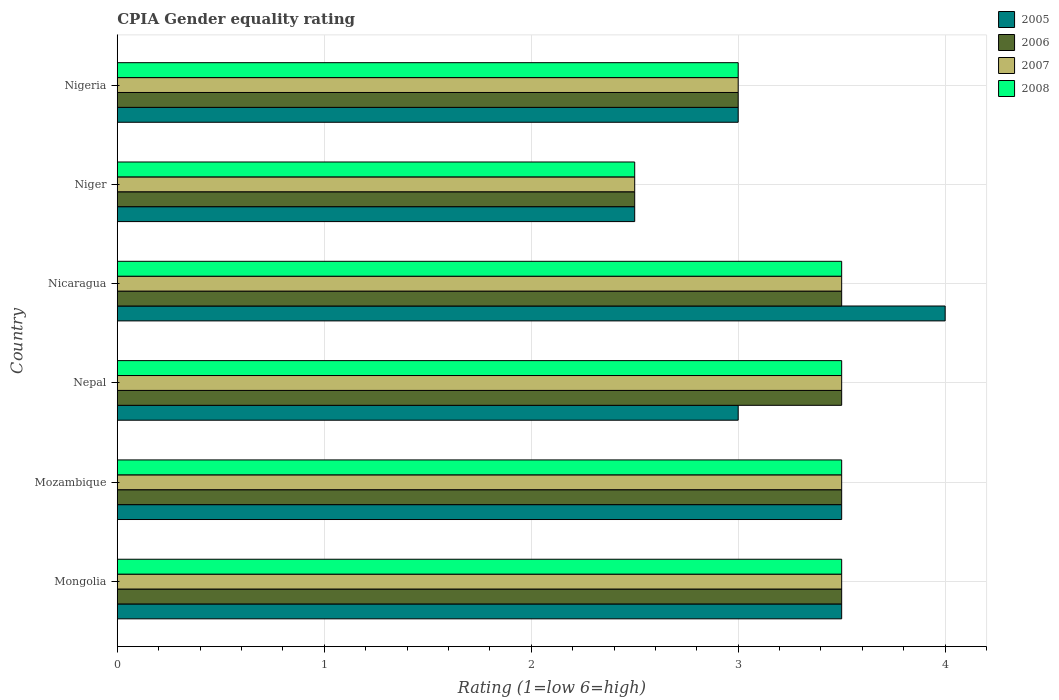Are the number of bars per tick equal to the number of legend labels?
Ensure brevity in your answer.  Yes. Are the number of bars on each tick of the Y-axis equal?
Ensure brevity in your answer.  Yes. How many bars are there on the 2nd tick from the bottom?
Give a very brief answer. 4. What is the label of the 2nd group of bars from the top?
Your answer should be very brief. Niger. In how many cases, is the number of bars for a given country not equal to the number of legend labels?
Make the answer very short. 0. In which country was the CPIA rating in 2007 maximum?
Give a very brief answer. Mongolia. In which country was the CPIA rating in 2006 minimum?
Give a very brief answer. Niger. What is the total CPIA rating in 2005 in the graph?
Your response must be concise. 19.5. What is the difference between the CPIA rating in 2008 in Mongolia and that in Niger?
Keep it short and to the point. 1. What is the difference between the CPIA rating in 2007 in Mozambique and the CPIA rating in 2008 in Nepal?
Your response must be concise. 0. What is the average CPIA rating in 2005 per country?
Offer a very short reply. 3.25. What is the difference between the CPIA rating in 2006 and CPIA rating in 2008 in Mozambique?
Ensure brevity in your answer.  0. What is the difference between the highest and the lowest CPIA rating in 2008?
Your answer should be compact. 1. What does the 2nd bar from the bottom in Nicaragua represents?
Give a very brief answer. 2006. How many bars are there?
Keep it short and to the point. 24. Are all the bars in the graph horizontal?
Give a very brief answer. Yes. What is the difference between two consecutive major ticks on the X-axis?
Your response must be concise. 1. Does the graph contain grids?
Make the answer very short. Yes. How are the legend labels stacked?
Offer a terse response. Vertical. What is the title of the graph?
Your answer should be very brief. CPIA Gender equality rating. Does "1983" appear as one of the legend labels in the graph?
Your response must be concise. No. What is the label or title of the Y-axis?
Offer a terse response. Country. What is the Rating (1=low 6=high) of 2005 in Mongolia?
Offer a very short reply. 3.5. What is the Rating (1=low 6=high) in 2006 in Mongolia?
Give a very brief answer. 3.5. What is the Rating (1=low 6=high) of 2007 in Mozambique?
Offer a terse response. 3.5. What is the Rating (1=low 6=high) in 2008 in Mozambique?
Your answer should be compact. 3.5. What is the Rating (1=low 6=high) of 2005 in Nepal?
Offer a very short reply. 3. What is the Rating (1=low 6=high) of 2006 in Nepal?
Your response must be concise. 3.5. What is the Rating (1=low 6=high) of 2007 in Nepal?
Keep it short and to the point. 3.5. What is the Rating (1=low 6=high) in 2008 in Nepal?
Offer a terse response. 3.5. What is the Rating (1=low 6=high) of 2006 in Niger?
Make the answer very short. 2.5. What is the Rating (1=low 6=high) in 2007 in Niger?
Give a very brief answer. 2.5. What is the Rating (1=low 6=high) of 2006 in Nigeria?
Make the answer very short. 3. What is the Rating (1=low 6=high) in 2007 in Nigeria?
Offer a very short reply. 3. What is the Rating (1=low 6=high) of 2008 in Nigeria?
Make the answer very short. 3. Across all countries, what is the maximum Rating (1=low 6=high) of 2005?
Offer a terse response. 4. Across all countries, what is the maximum Rating (1=low 6=high) of 2007?
Make the answer very short. 3.5. Across all countries, what is the maximum Rating (1=low 6=high) in 2008?
Offer a terse response. 3.5. Across all countries, what is the minimum Rating (1=low 6=high) in 2006?
Keep it short and to the point. 2.5. Across all countries, what is the minimum Rating (1=low 6=high) in 2007?
Provide a short and direct response. 2.5. What is the difference between the Rating (1=low 6=high) in 2005 in Mongolia and that in Mozambique?
Your answer should be very brief. 0. What is the difference between the Rating (1=low 6=high) in 2006 in Mongolia and that in Mozambique?
Your response must be concise. 0. What is the difference between the Rating (1=low 6=high) of 2007 in Mongolia and that in Mozambique?
Give a very brief answer. 0. What is the difference between the Rating (1=low 6=high) of 2005 in Mongolia and that in Nepal?
Provide a succinct answer. 0.5. What is the difference between the Rating (1=low 6=high) in 2006 in Mongolia and that in Nepal?
Offer a very short reply. 0. What is the difference between the Rating (1=low 6=high) in 2007 in Mongolia and that in Nepal?
Your answer should be very brief. 0. What is the difference between the Rating (1=low 6=high) in 2006 in Mongolia and that in Nicaragua?
Keep it short and to the point. 0. What is the difference between the Rating (1=low 6=high) of 2005 in Mongolia and that in Niger?
Offer a terse response. 1. What is the difference between the Rating (1=low 6=high) of 2005 in Mongolia and that in Nigeria?
Ensure brevity in your answer.  0.5. What is the difference between the Rating (1=low 6=high) of 2006 in Mongolia and that in Nigeria?
Your answer should be compact. 0.5. What is the difference between the Rating (1=low 6=high) of 2007 in Mongolia and that in Nigeria?
Give a very brief answer. 0.5. What is the difference between the Rating (1=low 6=high) in 2006 in Mozambique and that in Nepal?
Your answer should be compact. 0. What is the difference between the Rating (1=low 6=high) in 2008 in Mozambique and that in Nicaragua?
Ensure brevity in your answer.  0. What is the difference between the Rating (1=low 6=high) of 2005 in Mozambique and that in Niger?
Offer a very short reply. 1. What is the difference between the Rating (1=low 6=high) of 2005 in Mozambique and that in Nigeria?
Offer a terse response. 0.5. What is the difference between the Rating (1=low 6=high) of 2007 in Mozambique and that in Nigeria?
Your answer should be very brief. 0.5. What is the difference between the Rating (1=low 6=high) in 2005 in Nepal and that in Nicaragua?
Provide a short and direct response. -1. What is the difference between the Rating (1=low 6=high) of 2006 in Nepal and that in Nicaragua?
Offer a terse response. 0. What is the difference between the Rating (1=low 6=high) of 2007 in Nepal and that in Nicaragua?
Ensure brevity in your answer.  0. What is the difference between the Rating (1=low 6=high) of 2006 in Nepal and that in Niger?
Offer a very short reply. 1. What is the difference between the Rating (1=low 6=high) in 2008 in Nepal and that in Niger?
Your answer should be compact. 1. What is the difference between the Rating (1=low 6=high) in 2006 in Nepal and that in Nigeria?
Ensure brevity in your answer.  0.5. What is the difference between the Rating (1=low 6=high) in 2008 in Nepal and that in Nigeria?
Offer a very short reply. 0.5. What is the difference between the Rating (1=low 6=high) in 2005 in Nicaragua and that in Niger?
Your response must be concise. 1.5. What is the difference between the Rating (1=low 6=high) in 2006 in Nicaragua and that in Niger?
Ensure brevity in your answer.  1. What is the difference between the Rating (1=low 6=high) in 2007 in Nicaragua and that in Niger?
Ensure brevity in your answer.  1. What is the difference between the Rating (1=low 6=high) in 2007 in Nicaragua and that in Nigeria?
Provide a succinct answer. 0.5. What is the difference between the Rating (1=low 6=high) of 2005 in Niger and that in Nigeria?
Offer a very short reply. -0.5. What is the difference between the Rating (1=low 6=high) in 2007 in Niger and that in Nigeria?
Provide a short and direct response. -0.5. What is the difference between the Rating (1=low 6=high) of 2008 in Niger and that in Nigeria?
Provide a short and direct response. -0.5. What is the difference between the Rating (1=low 6=high) of 2005 in Mongolia and the Rating (1=low 6=high) of 2006 in Mozambique?
Provide a succinct answer. 0. What is the difference between the Rating (1=low 6=high) of 2005 in Mongolia and the Rating (1=low 6=high) of 2008 in Mozambique?
Provide a succinct answer. 0. What is the difference between the Rating (1=low 6=high) in 2006 in Mongolia and the Rating (1=low 6=high) in 2008 in Mozambique?
Keep it short and to the point. 0. What is the difference between the Rating (1=low 6=high) of 2005 in Mongolia and the Rating (1=low 6=high) of 2006 in Nepal?
Your response must be concise. 0. What is the difference between the Rating (1=low 6=high) of 2005 in Mongolia and the Rating (1=low 6=high) of 2008 in Nepal?
Make the answer very short. 0. What is the difference between the Rating (1=low 6=high) in 2007 in Mongolia and the Rating (1=low 6=high) in 2008 in Nepal?
Make the answer very short. 0. What is the difference between the Rating (1=low 6=high) in 2005 in Mongolia and the Rating (1=low 6=high) in 2007 in Niger?
Your answer should be very brief. 1. What is the difference between the Rating (1=low 6=high) of 2006 in Mongolia and the Rating (1=low 6=high) of 2008 in Niger?
Your response must be concise. 1. What is the difference between the Rating (1=low 6=high) in 2007 in Mongolia and the Rating (1=low 6=high) in 2008 in Niger?
Offer a very short reply. 1. What is the difference between the Rating (1=low 6=high) in 2005 in Mongolia and the Rating (1=low 6=high) in 2007 in Nigeria?
Provide a short and direct response. 0.5. What is the difference between the Rating (1=low 6=high) of 2005 in Mongolia and the Rating (1=low 6=high) of 2008 in Nigeria?
Your response must be concise. 0.5. What is the difference between the Rating (1=low 6=high) of 2006 in Mongolia and the Rating (1=low 6=high) of 2008 in Nigeria?
Give a very brief answer. 0.5. What is the difference between the Rating (1=low 6=high) in 2007 in Mongolia and the Rating (1=low 6=high) in 2008 in Nigeria?
Provide a short and direct response. 0.5. What is the difference between the Rating (1=low 6=high) in 2006 in Mozambique and the Rating (1=low 6=high) in 2007 in Nepal?
Your answer should be very brief. 0. What is the difference between the Rating (1=low 6=high) in 2006 in Mozambique and the Rating (1=low 6=high) in 2008 in Nepal?
Make the answer very short. 0. What is the difference between the Rating (1=low 6=high) of 2007 in Mozambique and the Rating (1=low 6=high) of 2008 in Nepal?
Offer a very short reply. 0. What is the difference between the Rating (1=low 6=high) in 2005 in Mozambique and the Rating (1=low 6=high) in 2008 in Nicaragua?
Make the answer very short. 0. What is the difference between the Rating (1=low 6=high) in 2006 in Mozambique and the Rating (1=low 6=high) in 2008 in Nicaragua?
Make the answer very short. 0. What is the difference between the Rating (1=low 6=high) of 2005 in Mozambique and the Rating (1=low 6=high) of 2007 in Niger?
Your response must be concise. 1. What is the difference between the Rating (1=low 6=high) in 2005 in Mozambique and the Rating (1=low 6=high) in 2008 in Niger?
Your answer should be very brief. 1. What is the difference between the Rating (1=low 6=high) in 2006 in Mozambique and the Rating (1=low 6=high) in 2007 in Niger?
Ensure brevity in your answer.  1. What is the difference between the Rating (1=low 6=high) of 2006 in Mozambique and the Rating (1=low 6=high) of 2008 in Niger?
Offer a very short reply. 1. What is the difference between the Rating (1=low 6=high) of 2007 in Mozambique and the Rating (1=low 6=high) of 2008 in Niger?
Offer a very short reply. 1. What is the difference between the Rating (1=low 6=high) of 2005 in Mozambique and the Rating (1=low 6=high) of 2007 in Nigeria?
Your answer should be compact. 0.5. What is the difference between the Rating (1=low 6=high) of 2006 in Mozambique and the Rating (1=low 6=high) of 2008 in Nigeria?
Your answer should be very brief. 0.5. What is the difference between the Rating (1=low 6=high) of 2007 in Mozambique and the Rating (1=low 6=high) of 2008 in Nigeria?
Provide a succinct answer. 0.5. What is the difference between the Rating (1=low 6=high) of 2005 in Nepal and the Rating (1=low 6=high) of 2008 in Nicaragua?
Offer a very short reply. -0.5. What is the difference between the Rating (1=low 6=high) of 2007 in Nepal and the Rating (1=low 6=high) of 2008 in Nicaragua?
Your answer should be compact. 0. What is the difference between the Rating (1=low 6=high) of 2005 in Nepal and the Rating (1=low 6=high) of 2006 in Niger?
Offer a terse response. 0.5. What is the difference between the Rating (1=low 6=high) of 2005 in Nepal and the Rating (1=low 6=high) of 2007 in Niger?
Ensure brevity in your answer.  0.5. What is the difference between the Rating (1=low 6=high) in 2005 in Nepal and the Rating (1=low 6=high) in 2008 in Niger?
Give a very brief answer. 0.5. What is the difference between the Rating (1=low 6=high) of 2006 in Nepal and the Rating (1=low 6=high) of 2007 in Niger?
Offer a terse response. 1. What is the difference between the Rating (1=low 6=high) in 2007 in Nepal and the Rating (1=low 6=high) in 2008 in Niger?
Offer a terse response. 1. What is the difference between the Rating (1=low 6=high) in 2005 in Nepal and the Rating (1=low 6=high) in 2006 in Nigeria?
Your answer should be very brief. 0. What is the difference between the Rating (1=low 6=high) of 2006 in Nepal and the Rating (1=low 6=high) of 2007 in Nigeria?
Provide a succinct answer. 0.5. What is the difference between the Rating (1=low 6=high) of 2006 in Nepal and the Rating (1=low 6=high) of 2008 in Nigeria?
Provide a short and direct response. 0.5. What is the difference between the Rating (1=low 6=high) in 2005 in Nicaragua and the Rating (1=low 6=high) in 2007 in Niger?
Provide a short and direct response. 1.5. What is the difference between the Rating (1=low 6=high) of 2006 in Nicaragua and the Rating (1=low 6=high) of 2008 in Niger?
Your response must be concise. 1. What is the difference between the Rating (1=low 6=high) of 2005 in Nicaragua and the Rating (1=low 6=high) of 2006 in Nigeria?
Ensure brevity in your answer.  1. What is the difference between the Rating (1=low 6=high) of 2005 in Nicaragua and the Rating (1=low 6=high) of 2007 in Nigeria?
Keep it short and to the point. 1. What is the difference between the Rating (1=low 6=high) of 2006 in Nicaragua and the Rating (1=low 6=high) of 2007 in Nigeria?
Your answer should be compact. 0.5. What is the difference between the Rating (1=low 6=high) of 2006 in Nicaragua and the Rating (1=low 6=high) of 2008 in Nigeria?
Keep it short and to the point. 0.5. What is the difference between the Rating (1=low 6=high) of 2007 in Nicaragua and the Rating (1=low 6=high) of 2008 in Nigeria?
Provide a short and direct response. 0.5. What is the difference between the Rating (1=low 6=high) of 2005 in Niger and the Rating (1=low 6=high) of 2007 in Nigeria?
Offer a very short reply. -0.5. What is the difference between the Rating (1=low 6=high) in 2006 in Niger and the Rating (1=low 6=high) in 2008 in Nigeria?
Your answer should be compact. -0.5. What is the difference between the Rating (1=low 6=high) of 2007 in Niger and the Rating (1=low 6=high) of 2008 in Nigeria?
Offer a terse response. -0.5. What is the average Rating (1=low 6=high) of 2006 per country?
Your answer should be compact. 3.25. What is the difference between the Rating (1=low 6=high) of 2005 and Rating (1=low 6=high) of 2008 in Mongolia?
Provide a short and direct response. 0. What is the difference between the Rating (1=low 6=high) of 2006 and Rating (1=low 6=high) of 2007 in Mongolia?
Offer a terse response. 0. What is the difference between the Rating (1=low 6=high) of 2006 and Rating (1=low 6=high) of 2008 in Mongolia?
Make the answer very short. 0. What is the difference between the Rating (1=low 6=high) in 2007 and Rating (1=low 6=high) in 2008 in Mongolia?
Make the answer very short. 0. What is the difference between the Rating (1=low 6=high) of 2006 and Rating (1=low 6=high) of 2007 in Mozambique?
Ensure brevity in your answer.  0. What is the difference between the Rating (1=low 6=high) of 2006 and Rating (1=low 6=high) of 2008 in Mozambique?
Give a very brief answer. 0. What is the difference between the Rating (1=low 6=high) in 2007 and Rating (1=low 6=high) in 2008 in Mozambique?
Offer a very short reply. 0. What is the difference between the Rating (1=low 6=high) of 2005 and Rating (1=low 6=high) of 2006 in Nepal?
Your answer should be very brief. -0.5. What is the difference between the Rating (1=low 6=high) of 2006 and Rating (1=low 6=high) of 2007 in Nepal?
Your response must be concise. 0. What is the difference between the Rating (1=low 6=high) of 2006 and Rating (1=low 6=high) of 2008 in Nepal?
Your answer should be compact. 0. What is the difference between the Rating (1=low 6=high) of 2007 and Rating (1=low 6=high) of 2008 in Nepal?
Ensure brevity in your answer.  0. What is the difference between the Rating (1=low 6=high) in 2005 and Rating (1=low 6=high) in 2007 in Nicaragua?
Your answer should be very brief. 0.5. What is the difference between the Rating (1=low 6=high) in 2005 and Rating (1=low 6=high) in 2008 in Nicaragua?
Make the answer very short. 0.5. What is the difference between the Rating (1=low 6=high) in 2007 and Rating (1=low 6=high) in 2008 in Niger?
Give a very brief answer. 0. What is the difference between the Rating (1=low 6=high) of 2005 and Rating (1=low 6=high) of 2008 in Nigeria?
Offer a very short reply. 0. What is the difference between the Rating (1=low 6=high) in 2006 and Rating (1=low 6=high) in 2007 in Nigeria?
Provide a short and direct response. 0. What is the difference between the Rating (1=low 6=high) of 2006 and Rating (1=low 6=high) of 2008 in Nigeria?
Your response must be concise. 0. What is the difference between the Rating (1=low 6=high) of 2007 and Rating (1=low 6=high) of 2008 in Nigeria?
Give a very brief answer. 0. What is the ratio of the Rating (1=low 6=high) in 2006 in Mongolia to that in Mozambique?
Your answer should be very brief. 1. What is the ratio of the Rating (1=low 6=high) of 2008 in Mongolia to that in Mozambique?
Provide a succinct answer. 1. What is the ratio of the Rating (1=low 6=high) of 2005 in Mongolia to that in Nicaragua?
Your answer should be very brief. 0.88. What is the ratio of the Rating (1=low 6=high) in 2007 in Mongolia to that in Nicaragua?
Provide a succinct answer. 1. What is the ratio of the Rating (1=low 6=high) of 2008 in Mongolia to that in Nicaragua?
Offer a very short reply. 1. What is the ratio of the Rating (1=low 6=high) in 2006 in Mongolia to that in Niger?
Make the answer very short. 1.4. What is the ratio of the Rating (1=low 6=high) of 2006 in Mongolia to that in Nigeria?
Offer a terse response. 1.17. What is the ratio of the Rating (1=low 6=high) in 2008 in Mongolia to that in Nigeria?
Offer a very short reply. 1.17. What is the ratio of the Rating (1=low 6=high) of 2005 in Mozambique to that in Nepal?
Keep it short and to the point. 1.17. What is the ratio of the Rating (1=low 6=high) in 2006 in Mozambique to that in Nepal?
Offer a very short reply. 1. What is the ratio of the Rating (1=low 6=high) of 2007 in Mozambique to that in Nepal?
Offer a terse response. 1. What is the ratio of the Rating (1=low 6=high) in 2006 in Mozambique to that in Nicaragua?
Make the answer very short. 1. What is the ratio of the Rating (1=low 6=high) in 2007 in Mozambique to that in Nicaragua?
Keep it short and to the point. 1. What is the ratio of the Rating (1=low 6=high) in 2008 in Mozambique to that in Nicaragua?
Your answer should be compact. 1. What is the ratio of the Rating (1=low 6=high) of 2008 in Mozambique to that in Niger?
Offer a terse response. 1.4. What is the ratio of the Rating (1=low 6=high) in 2005 in Mozambique to that in Nigeria?
Provide a short and direct response. 1.17. What is the ratio of the Rating (1=low 6=high) of 2006 in Mozambique to that in Nigeria?
Make the answer very short. 1.17. What is the ratio of the Rating (1=low 6=high) of 2007 in Mozambique to that in Nigeria?
Your answer should be compact. 1.17. What is the ratio of the Rating (1=low 6=high) of 2005 in Nepal to that in Nicaragua?
Offer a terse response. 0.75. What is the ratio of the Rating (1=low 6=high) in 2008 in Nepal to that in Nicaragua?
Your answer should be very brief. 1. What is the ratio of the Rating (1=low 6=high) of 2006 in Nepal to that in Niger?
Provide a succinct answer. 1.4. What is the ratio of the Rating (1=low 6=high) in 2008 in Nepal to that in Niger?
Give a very brief answer. 1.4. What is the ratio of the Rating (1=low 6=high) of 2005 in Nepal to that in Nigeria?
Keep it short and to the point. 1. What is the ratio of the Rating (1=low 6=high) of 2006 in Nepal to that in Nigeria?
Ensure brevity in your answer.  1.17. What is the ratio of the Rating (1=low 6=high) of 2007 in Nepal to that in Nigeria?
Offer a very short reply. 1.17. What is the ratio of the Rating (1=low 6=high) in 2008 in Nepal to that in Nigeria?
Your answer should be compact. 1.17. What is the ratio of the Rating (1=low 6=high) in 2006 in Nicaragua to that in Niger?
Your answer should be compact. 1.4. What is the ratio of the Rating (1=low 6=high) of 2007 in Nicaragua to that in Niger?
Your response must be concise. 1.4. What is the ratio of the Rating (1=low 6=high) in 2006 in Nicaragua to that in Nigeria?
Make the answer very short. 1.17. What is the ratio of the Rating (1=low 6=high) of 2006 in Niger to that in Nigeria?
Offer a terse response. 0.83. What is the difference between the highest and the second highest Rating (1=low 6=high) of 2005?
Your response must be concise. 0.5. What is the difference between the highest and the second highest Rating (1=low 6=high) of 2006?
Provide a succinct answer. 0. What is the difference between the highest and the second highest Rating (1=low 6=high) in 2007?
Your answer should be very brief. 0. What is the difference between the highest and the second highest Rating (1=low 6=high) of 2008?
Ensure brevity in your answer.  0. What is the difference between the highest and the lowest Rating (1=low 6=high) of 2005?
Your answer should be very brief. 1.5. What is the difference between the highest and the lowest Rating (1=low 6=high) in 2007?
Make the answer very short. 1. 